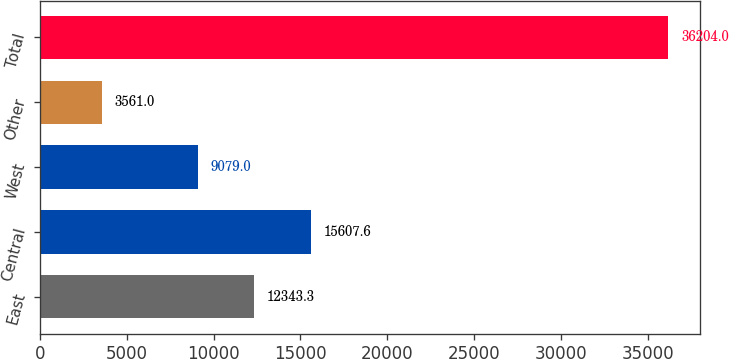<chart> <loc_0><loc_0><loc_500><loc_500><bar_chart><fcel>East<fcel>Central<fcel>West<fcel>Other<fcel>Total<nl><fcel>12343.3<fcel>15607.6<fcel>9079<fcel>3561<fcel>36204<nl></chart> 